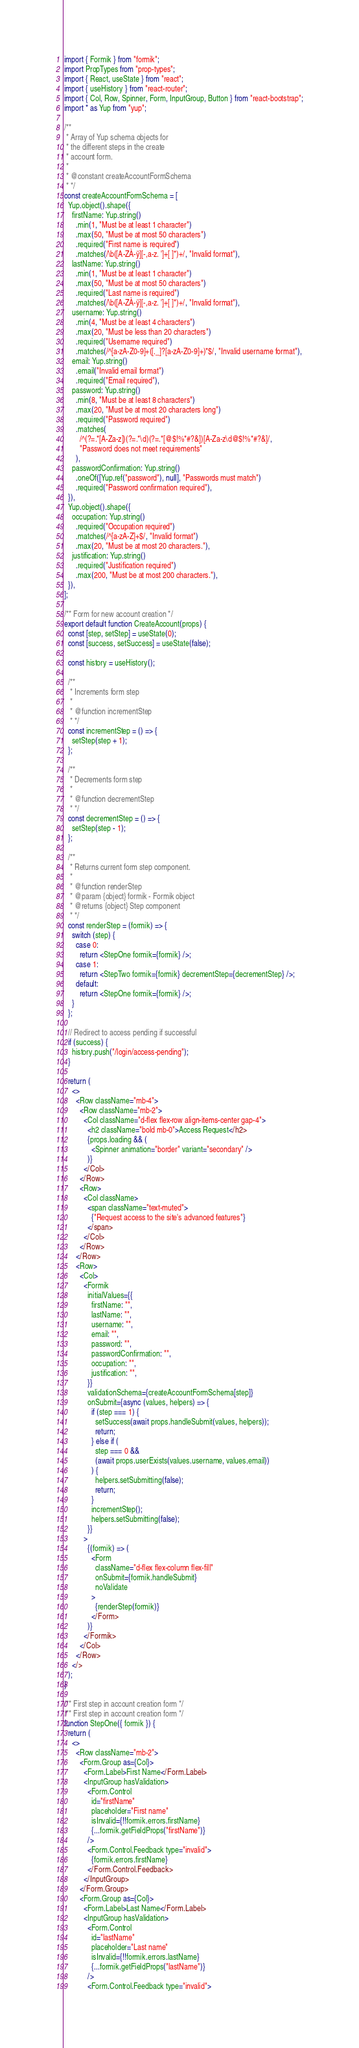<code> <loc_0><loc_0><loc_500><loc_500><_JavaScript_>import { Formik } from "formik";
import PropTypes from "prop-types";
import { React, useState } from "react";
import { useHistory } from "react-router";
import { Col, Row, Spinner, Form, InputGroup, Button } from "react-bootstrap";
import * as Yup from "yup";

/**
 * Array of Yup schema objects for
 * the different steps in the create
 * account form.
 *
 * @constant createAccountFormSchema
 * */
const createAccountFormSchema = [
  Yup.object().shape({
    firstName: Yup.string()
      .min(1, "Must be at least 1 character")
      .max(50, "Must be at most 50 characters")
      .required("First name is required")
      .matches(/\b([A-ZÀ-ÿ][-,a-z. ']+[ ]*)+/, "Invalid format"),
    lastName: Yup.string()
      .min(1, "Must be at least 1 character")
      .max(50, "Must be at most 50 characters")
      .required("Last name is required")
      .matches(/\b([A-ZÀ-ÿ][-,a-z. ']+[ ]*)+/, "Invalid format"),
    username: Yup.string()
      .min(4, "Must be at least 4 characters")
      .max(20, "Must be less than 20 characters")
      .required("Username required")
      .matches(/^[a-zA-Z0-9]+([._]?[a-zA-Z0-9]+)*$/, "Invalid username format"),
    email: Yup.string()
      .email("Invalid email format")
      .required("Email required"),
    password: Yup.string()
      .min(8, "Must be at least 8 characters")
      .max(20, "Must be at most 20 characters long")
      .required("Password required")
      .matches(
        /^(?=.*[A-Za-z])(?=.*\d)(?=.*[@$!%*#?&])[A-Za-z\d@$!%*#?&]/,
        "Password does not meet requirements"
      ),
    passwordConfirmation: Yup.string()
      .oneOf([Yup.ref("password"), null], "Passwords must match")
      .required("Password confirmation required"),
  }),
  Yup.object().shape({
    occupation: Yup.string()
      .required("Occupation required")
      .matches(/^[a-zA-Z]+$/, "Invalid format")
      .max(20, "Must be at most 20 characters."),
    justification: Yup.string()
      .required("Justification required")
      .max(200, "Must be at most 200 characters."),
  }),
];

/** Form for new account creation */
export default function CreateAccount(props) {
  const [step, setStep] = useState(0);
  const [success, setSuccess] = useState(false);

  const history = useHistory();

  /**
   * Increments form step
   *
   * @function incrementStep
   * */
  const incrementStep = () => {
    setStep(step + 1);
  };

  /**
   * Decrements form step
   *
   * @function decrementStep
   * */
  const decrementStep = () => {
    setStep(step - 1);
  };

  /**
   * Returns current form step component.
   *
   * @function renderStep
   * @param {object} formik - Formik object
   * @returns {object} Step component
   * */
  const renderStep = (formik) => {
    switch (step) {
      case 0:
        return <StepOne formik={formik} />;
      case 1:
        return <StepTwo formik={formik} decrementStep={decrementStep} />;
      default:
        return <StepOne formik={formik} />;
    }
  };

  // Redirect to access pending if successful
  if (success) {
    history.push("/login/access-pending");
  }

  return (
    <>
      <Row className="mb-4">
        <Row className="mb-2">
          <Col className="d-flex flex-row align-items-center gap-4">
            <h2 className="bold mb-0">Access Request</h2>
            {props.loading && (
              <Spinner animation="border" variant="secondary" />
            )}
          </Col>
        </Row>
        <Row>
          <Col className>
            <span className="text-muted">
              {"Request access to the site's advanced features"}
            </span>
          </Col>
        </Row>
      </Row>
      <Row>
        <Col>
          <Formik
            initialValues={{
              firstName: "",
              lastName: "",
              username: "",
              email: "",
              password: "",
              passwordConfirmation: "",
              occupation: "",
              justification: "",
            }}
            validationSchema={createAccountFormSchema[step]}
            onSubmit={async (values, helpers) => {
              if (step === 1) {
                setSuccess(await props.handleSubmit(values, helpers));
                return;
              } else if (
                step === 0 &&
                (await props.userExists(values.username, values.email))
              ) {
                helpers.setSubmitting(false);
                return;
              }
              incrementStep();
              helpers.setSubmitting(false);
            }}
          >
            {(formik) => (
              <Form
                className="d-flex flex-column flex-fill"
                onSubmit={formik.handleSubmit}
                noValidate
              >
                {renderStep(formik)}
              </Form>
            )}
          </Formik>
        </Col>
      </Row>
    </>
  );
}

/** First step in account creation form */
/** First step in account creation form */
function StepOne({ formik }) {
  return (
    <>
      <Row className="mb-2">
        <Form.Group as={Col}>
          <Form.Label>First Name</Form.Label>
          <InputGroup hasValidation>
            <Form.Control
              id="firstName"
              placeholder="First name"
              isInvalid={!!formik.errors.firstName}
              {...formik.getFieldProps("firstName")}
            />
            <Form.Control.Feedback type="invalid">
              {formik.errors.firstName}
            </Form.Control.Feedback>
          </InputGroup>
        </Form.Group>
        <Form.Group as={Col}>
          <Form.Label>Last Name</Form.Label>
          <InputGroup hasValidation>
            <Form.Control
              id="lastName"
              placeholder="Last name"
              isInvalid={!!formik.errors.lastName}
              {...formik.getFieldProps("lastName")}
            />
            <Form.Control.Feedback type="invalid"></code> 